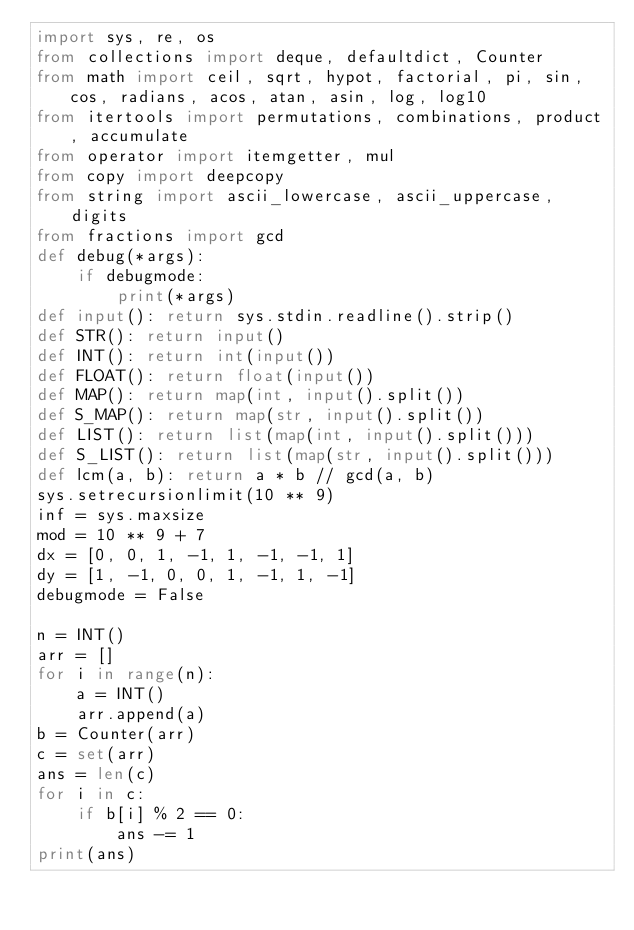<code> <loc_0><loc_0><loc_500><loc_500><_Python_>import sys, re, os
from collections import deque, defaultdict, Counter
from math import ceil, sqrt, hypot, factorial, pi, sin, cos, radians, acos, atan, asin, log, log10
from itertools import permutations, combinations, product, accumulate
from operator import itemgetter, mul
from copy import deepcopy
from string import ascii_lowercase, ascii_uppercase, digits
from fractions import gcd
def debug(*args):
    if debugmode:
        print(*args)
def input(): return sys.stdin.readline().strip()
def STR(): return input()
def INT(): return int(input())
def FLOAT(): return float(input())
def MAP(): return map(int, input().split())
def S_MAP(): return map(str, input().split())
def LIST(): return list(map(int, input().split()))
def S_LIST(): return list(map(str, input().split()))
def lcm(a, b): return a * b // gcd(a, b)
sys.setrecursionlimit(10 ** 9)
inf = sys.maxsize
mod = 10 ** 9 + 7
dx = [0, 0, 1, -1, 1, -1, -1, 1]
dy = [1, -1, 0, 0, 1, -1, 1, -1]
debugmode = False

n = INT()
arr = []
for i in range(n):
    a = INT()
    arr.append(a)
b = Counter(arr)
c = set(arr)
ans = len(c)
for i in c:
    if b[i] % 2 == 0:
        ans -= 1
print(ans)</code> 